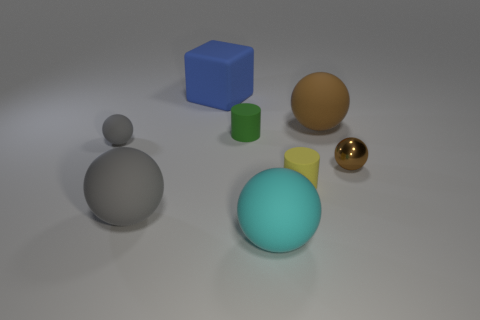Subtract 1 balls. How many balls are left? 4 Subtract all cyan spheres. How many spheres are left? 4 Subtract all metallic spheres. How many spheres are left? 4 Add 1 tiny matte things. How many objects exist? 9 Subtract all green spheres. Subtract all green cylinders. How many spheres are left? 5 Subtract all cubes. How many objects are left? 7 Subtract 1 green cylinders. How many objects are left? 7 Subtract all rubber cubes. Subtract all green matte cylinders. How many objects are left? 6 Add 3 large brown matte objects. How many large brown matte objects are left? 4 Add 7 big cyan blocks. How many big cyan blocks exist? 7 